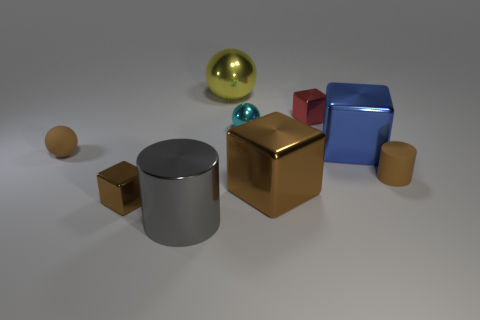Is there another tiny thing of the same shape as the blue shiny thing?
Keep it short and to the point. Yes. What material is the small cylinder?
Keep it short and to the point. Rubber. There is a brown object that is to the left of the blue block and to the right of the big yellow metal object; what size is it?
Your answer should be compact. Large. There is a sphere that is the same color as the rubber cylinder; what material is it?
Offer a very short reply. Rubber. How many green matte balls are there?
Provide a succinct answer. 0. Is the number of brown cylinders less than the number of large gray rubber balls?
Make the answer very short. No. What is the material of the cylinder that is the same size as the brown ball?
Ensure brevity in your answer.  Rubber. What number of things are big blue objects or small matte objects?
Keep it short and to the point. 3. What number of objects are on the left side of the big blue shiny thing and in front of the small red block?
Offer a terse response. 5. Is the number of small brown cylinders that are behind the large brown metal thing less than the number of tiny things?
Provide a succinct answer. Yes. 